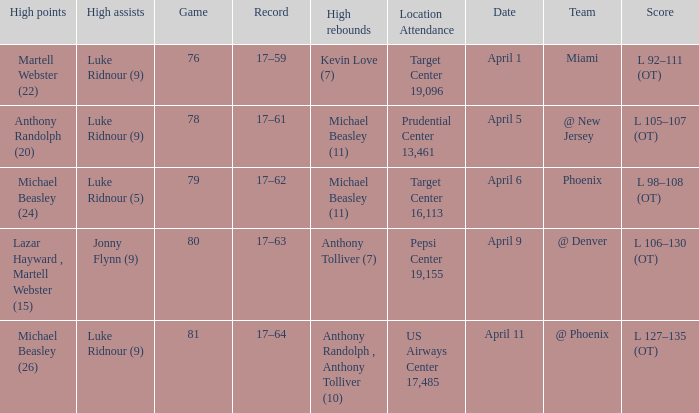What was the score in the game in which Michael Beasley (26) did the high points? L 127–135 (OT). 